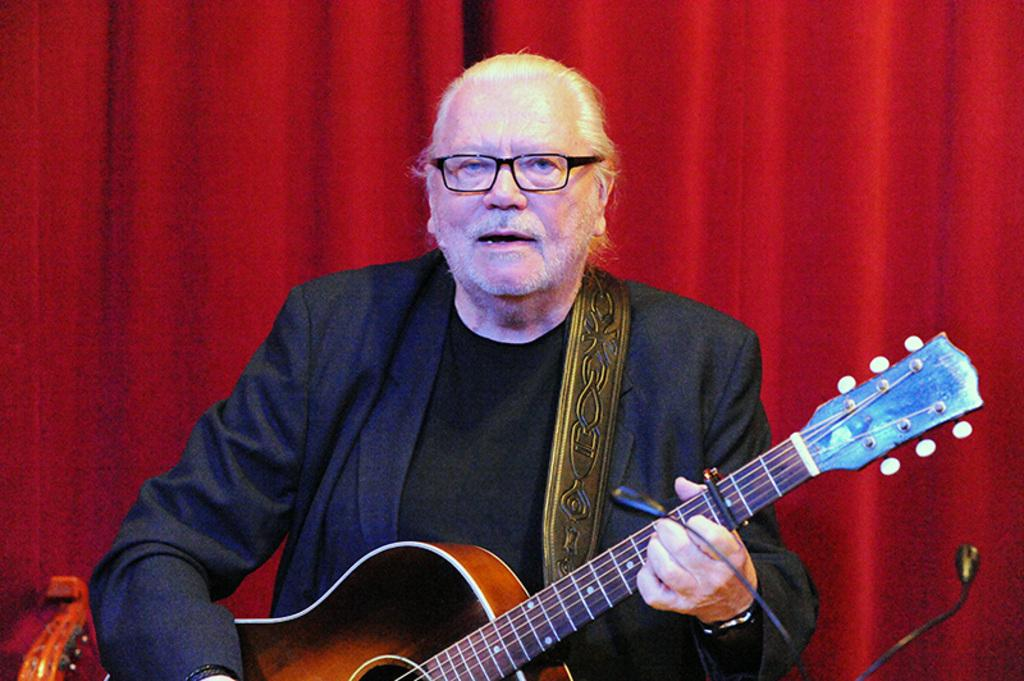What color is the curtain in the image? The curtain in the image is red. What is the man in the image doing? The man in the image is holding a guitar. What type of brush is the man using to paint on the curtain? There is no brush present in the image. The image features a red color curtain and a man holding a guitar. 